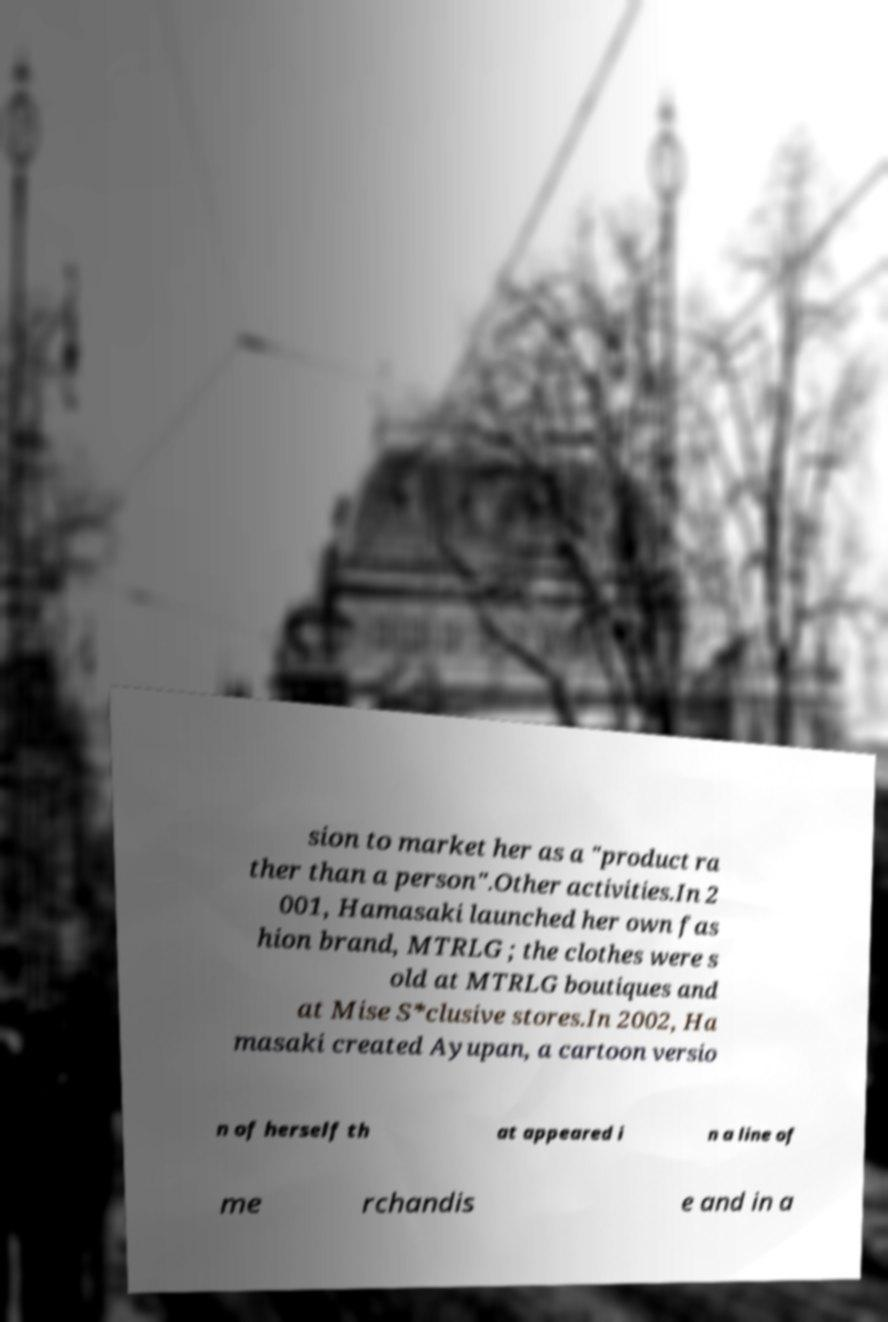Can you accurately transcribe the text from the provided image for me? sion to market her as a "product ra ther than a person".Other activities.In 2 001, Hamasaki launched her own fas hion brand, MTRLG ; the clothes were s old at MTRLG boutiques and at Mise S*clusive stores.In 2002, Ha masaki created Ayupan, a cartoon versio n of herself th at appeared i n a line of me rchandis e and in a 